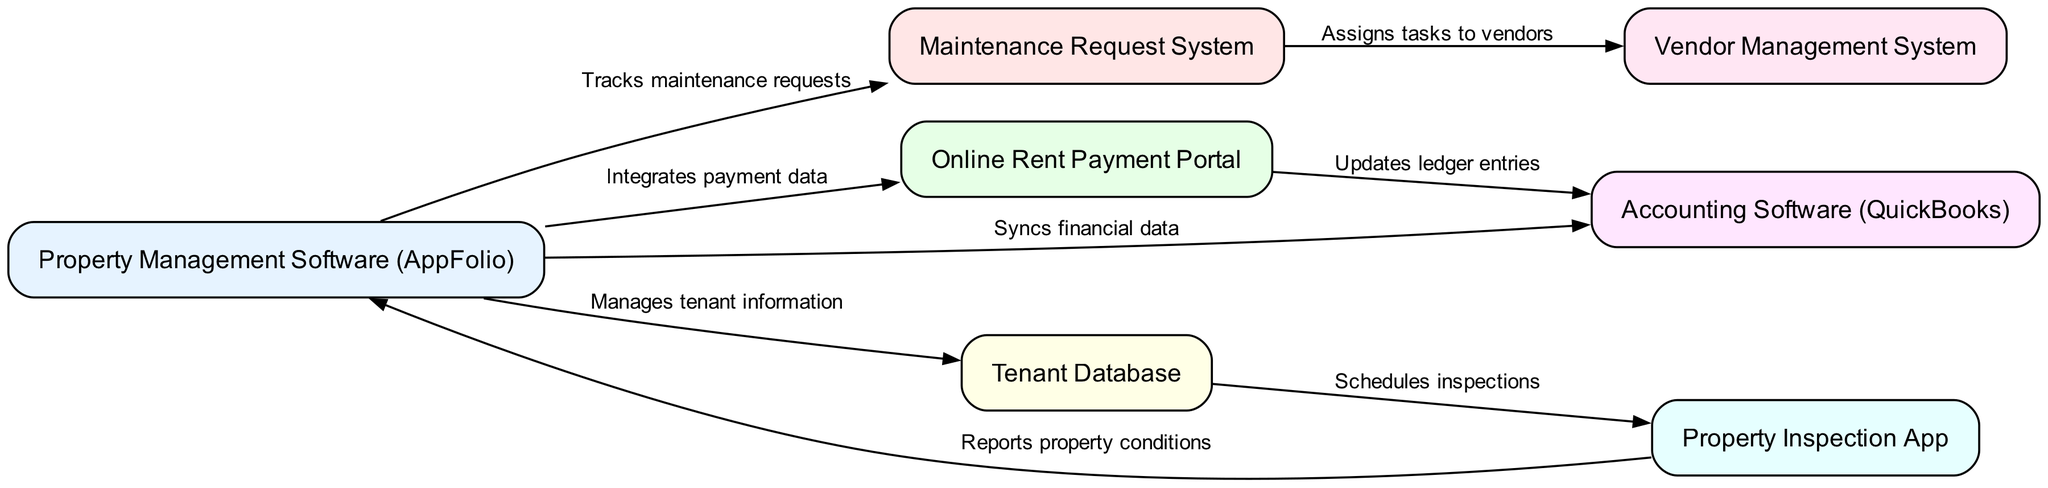What is the label of node 1? The label of node 1 is defined in the data provided, where node 1 is represented as "Property Management Software (AppFolio)".
Answer: Property Management Software (AppFolio) How many nodes are in the diagram? The diagram lists a total of 7 nodes in the data, including systems for maintenance, rent collection, and financial reporting.
Answer: 7 What does the edge between node 1 and node 2 represent? The edge between node 1 (Property Management Software) and node 2 (Maintenance Request System) is labeled "Tracks maintenance requests," indicating the relationship of tracking between these two systems.
Answer: Tracks maintenance requests Which software updates ledger entries? The online rent payment portal (node 3) connects to the accounting software (node 4) through the edge labeled "Updates ledger entries," indicating this relationship.
Answer: Online Rent Payment Portal Which system schedules inspections? The tenant database (node 5) connects to the property inspection app (node 6) through the edge labeled "Schedules inspections," indicating that the tenant database is responsible for scheduling.
Answer: Tenant Database How many edges are in the diagram? By counting the connections (or edges) described in the data, we find there are 7 edges linking the different systems in the diagram.
Answer: 7 What type of data does the property management software sync with the accounting software? The property management software (node 1) syncs "financial data" with the accounting software (node 4), as indicated in the relationship defined in the edge.
Answer: Financial data What is the purpose of the vendor management system related to maintenance requests? The vendor management system (node 7) is related to the maintenance request system (node 2) through the edge labeled "Assigns tasks to vendors," meaning it helps in assigning maintenance tasks to the vendors.
Answer: Assigns tasks to vendors Which node reports property conditions back to the property management software? The property inspection app (node 6) reports property conditions back to the property management software (node 1) through the edge labeled "Reports property conditions."
Answer: Property Inspection App 